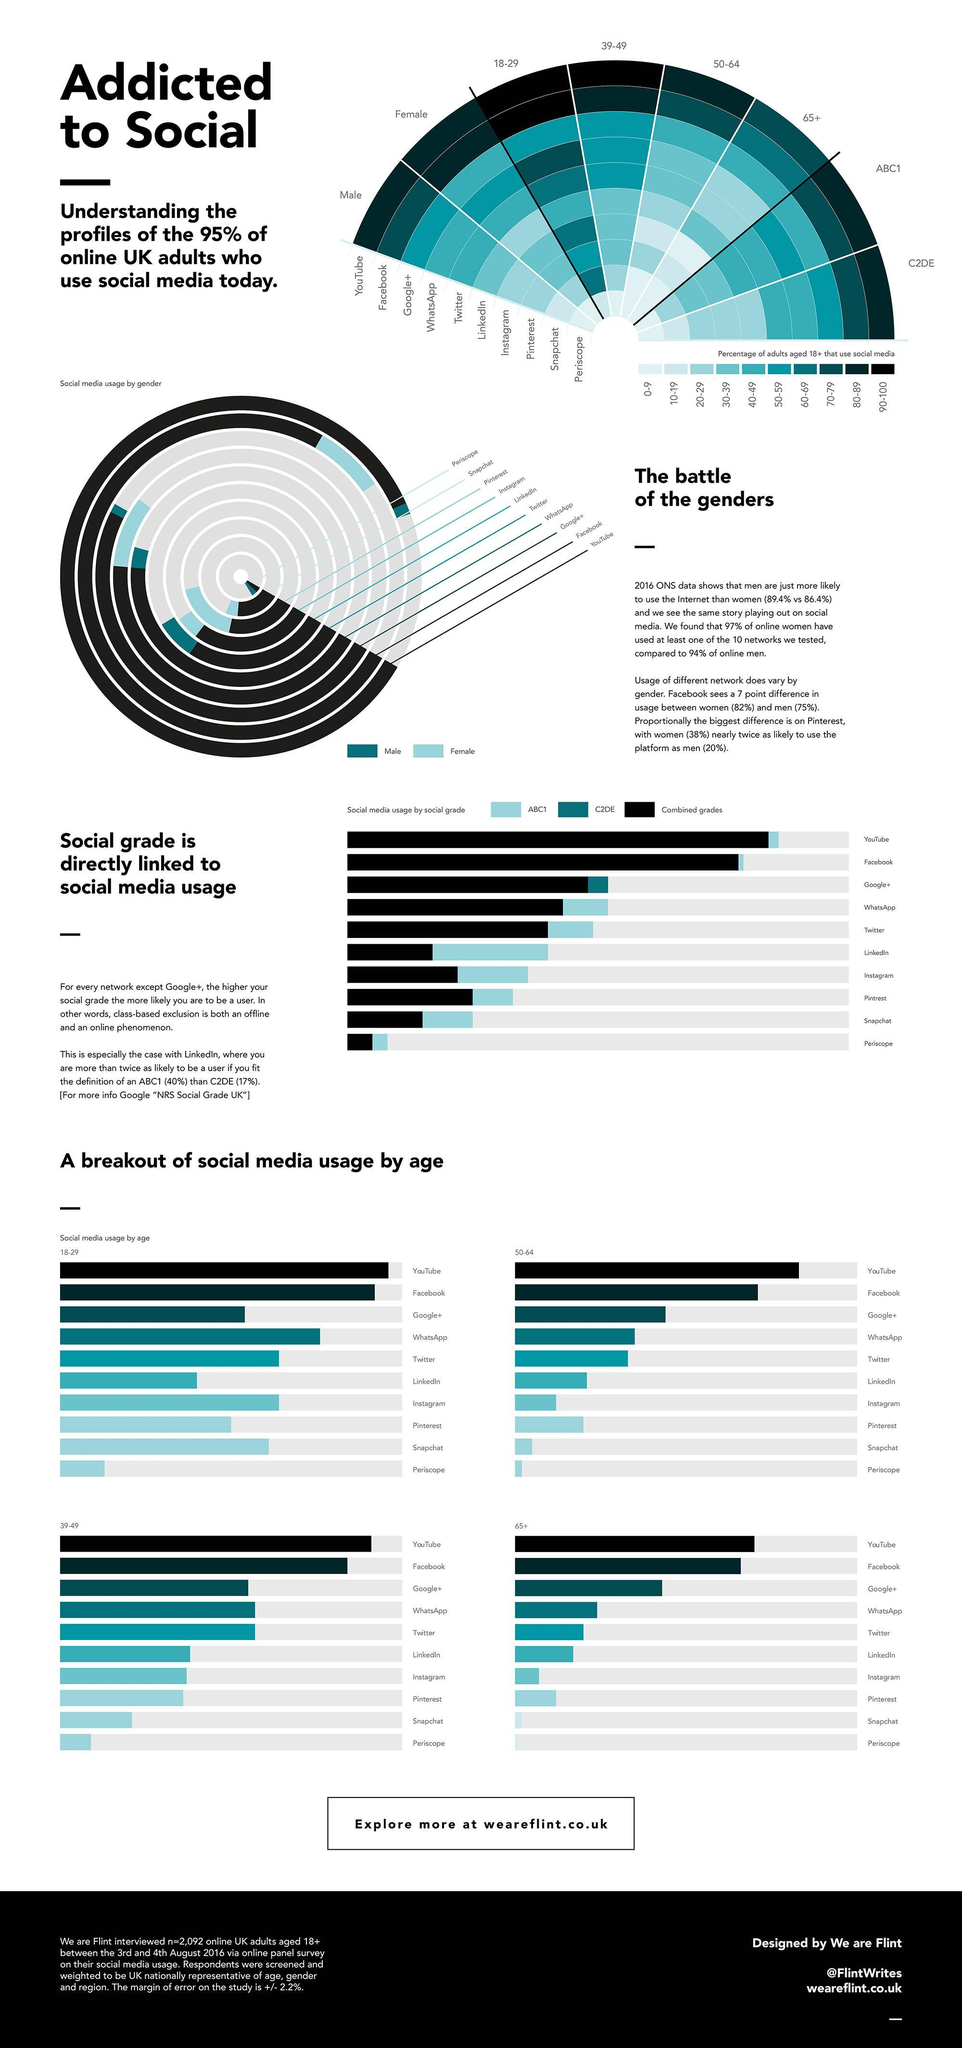Who uses Pinterest more, men or women?
Answer the question with a short phrase. women What percentage of 18-29 year old people use snapchat? 60-69 Which social grade uses Google+ more? C2DE What percentage of 18-29 year old people use YouTube? 90-100 What is the third most used social media by 50-64 year olds? Google+ Who uses YouTube more, male or female? male Who uses Twitter more, male or female? male What is the second most used social media by 50-64 year olds? Facebook What percentage of males use periscope? 0-9 What percentage of 39-49 year old people use YouTube? 90-100 Who uses WhatsApp more, male or female? female Who uses Facebook more, men or women? women What percentage of 65+ year old people use YouTube? 70-79 Who uses Periscope more, male or female? male Which social grade uses Facebook more? ABC1 What is the least used social media app by 18-29 year olds? periscope What percentage of 18-29 year old people use Facebook? 90-100 What is the third most used social media by 65+ year olds? Google+ 